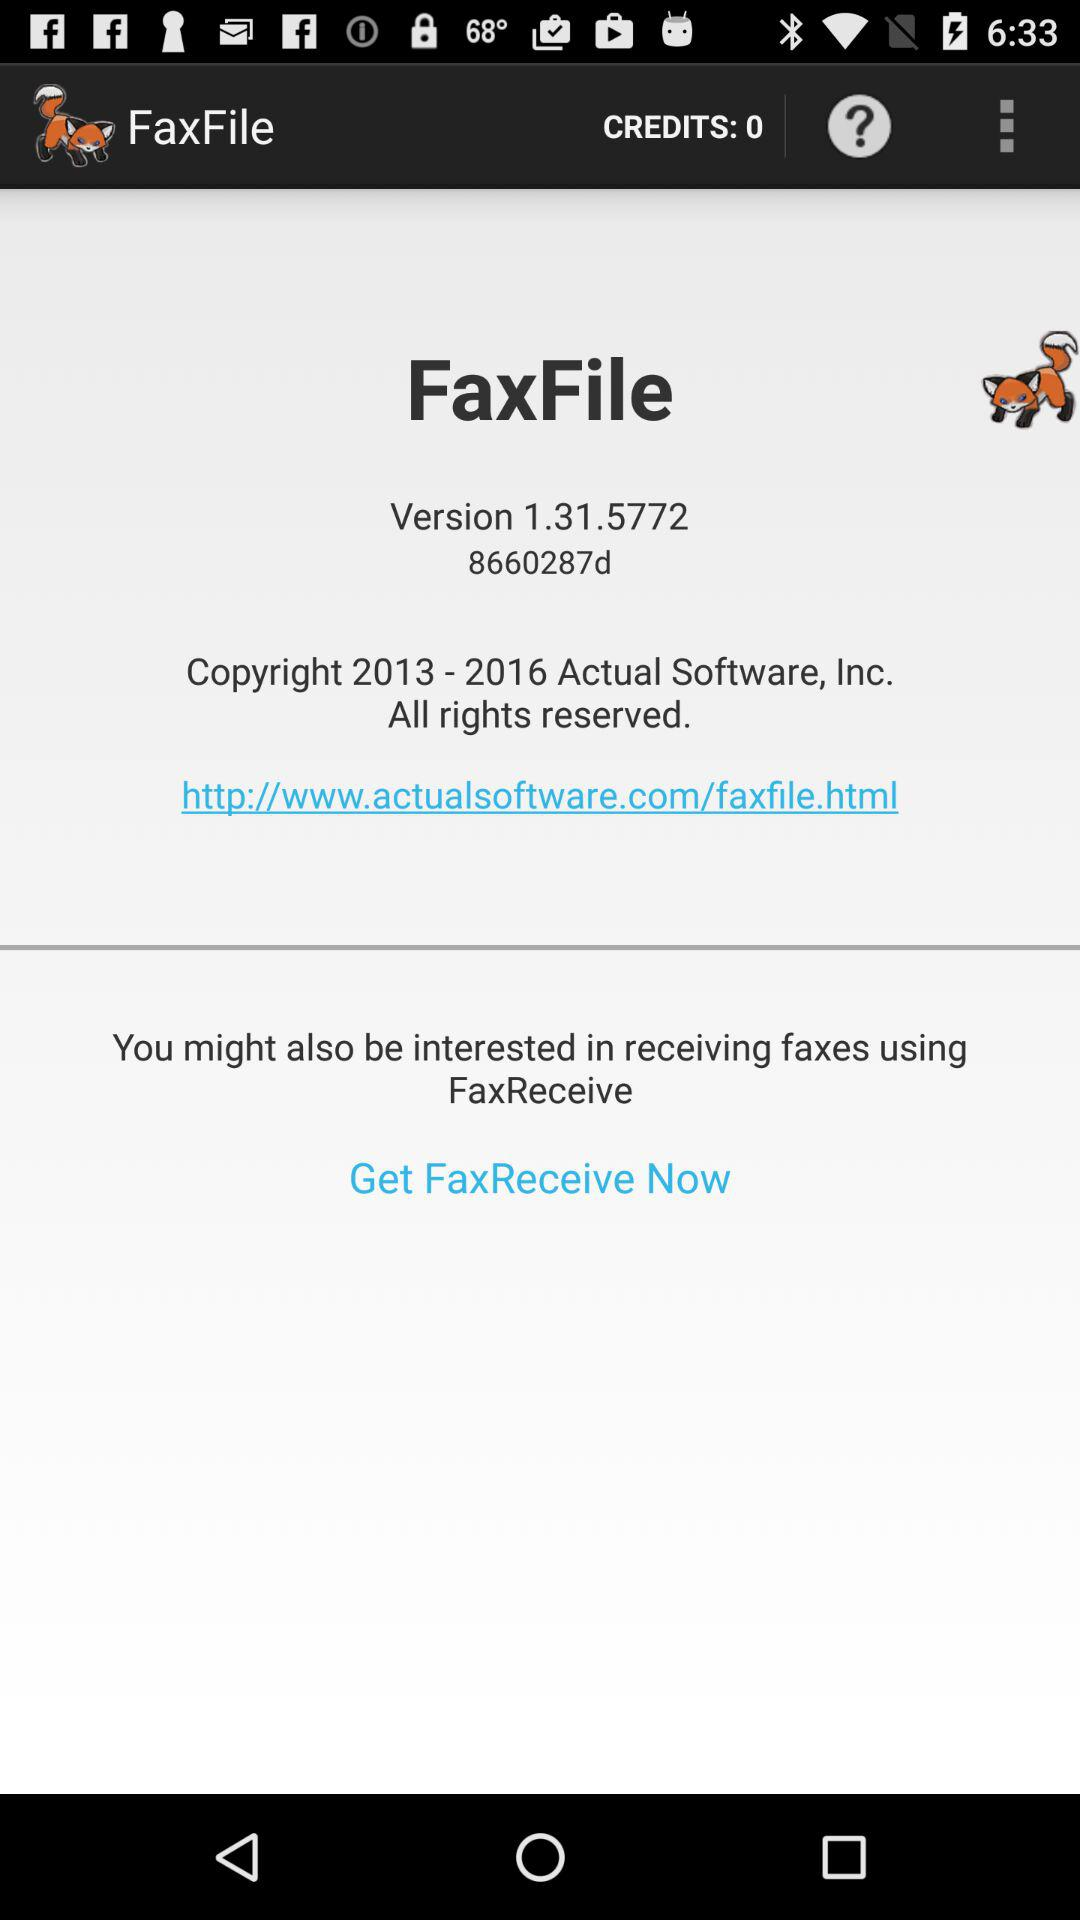How many new features are added to this version?
When the provided information is insufficient, respond with <no answer>. <no answer> 